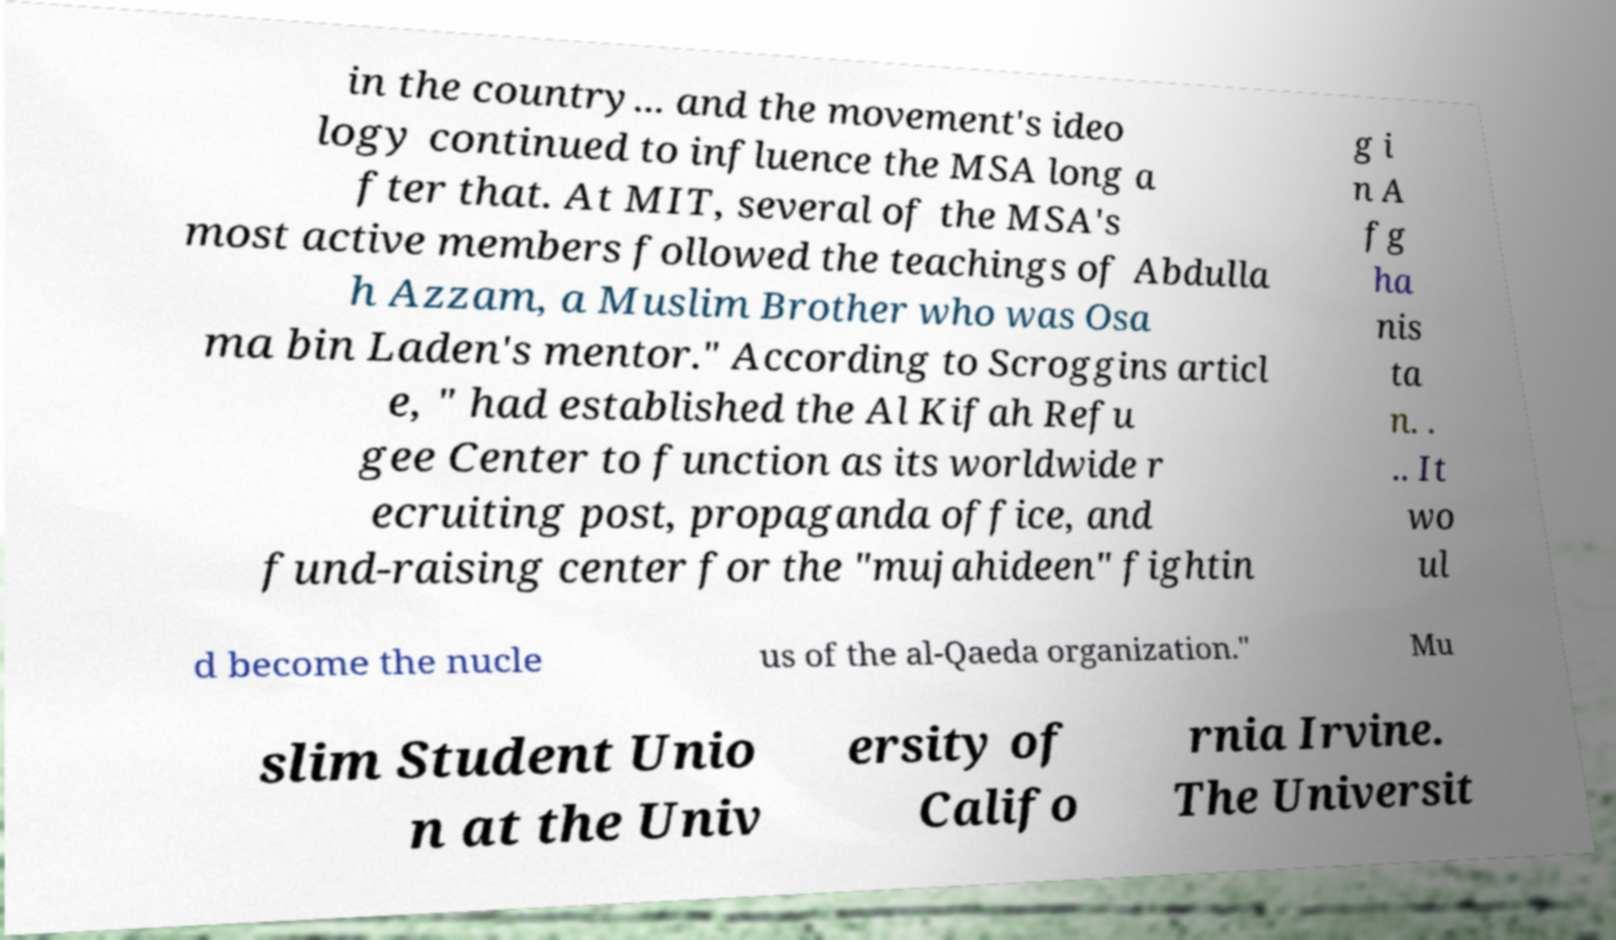I need the written content from this picture converted into text. Can you do that? in the country... and the movement's ideo logy continued to influence the MSA long a fter that. At MIT, several of the MSA's most active members followed the teachings of Abdulla h Azzam, a Muslim Brother who was Osa ma bin Laden's mentor." According to Scroggins articl e, " had established the Al Kifah Refu gee Center to function as its worldwide r ecruiting post, propaganda office, and fund-raising center for the "mujahideen" fightin g i n A fg ha nis ta n. . .. It wo ul d become the nucle us of the al-Qaeda organization." Mu slim Student Unio n at the Univ ersity of Califo rnia Irvine. The Universit 